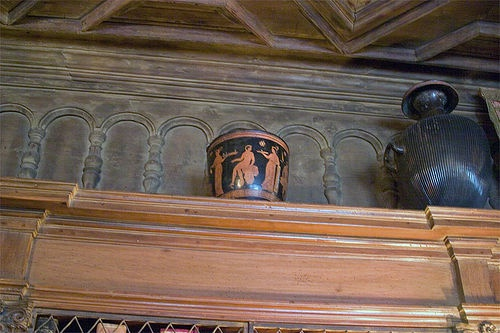Describe the objects in this image and their specific colors. I can see vase in black, gray, and darkblue tones and vase in black, gray, and maroon tones in this image. 